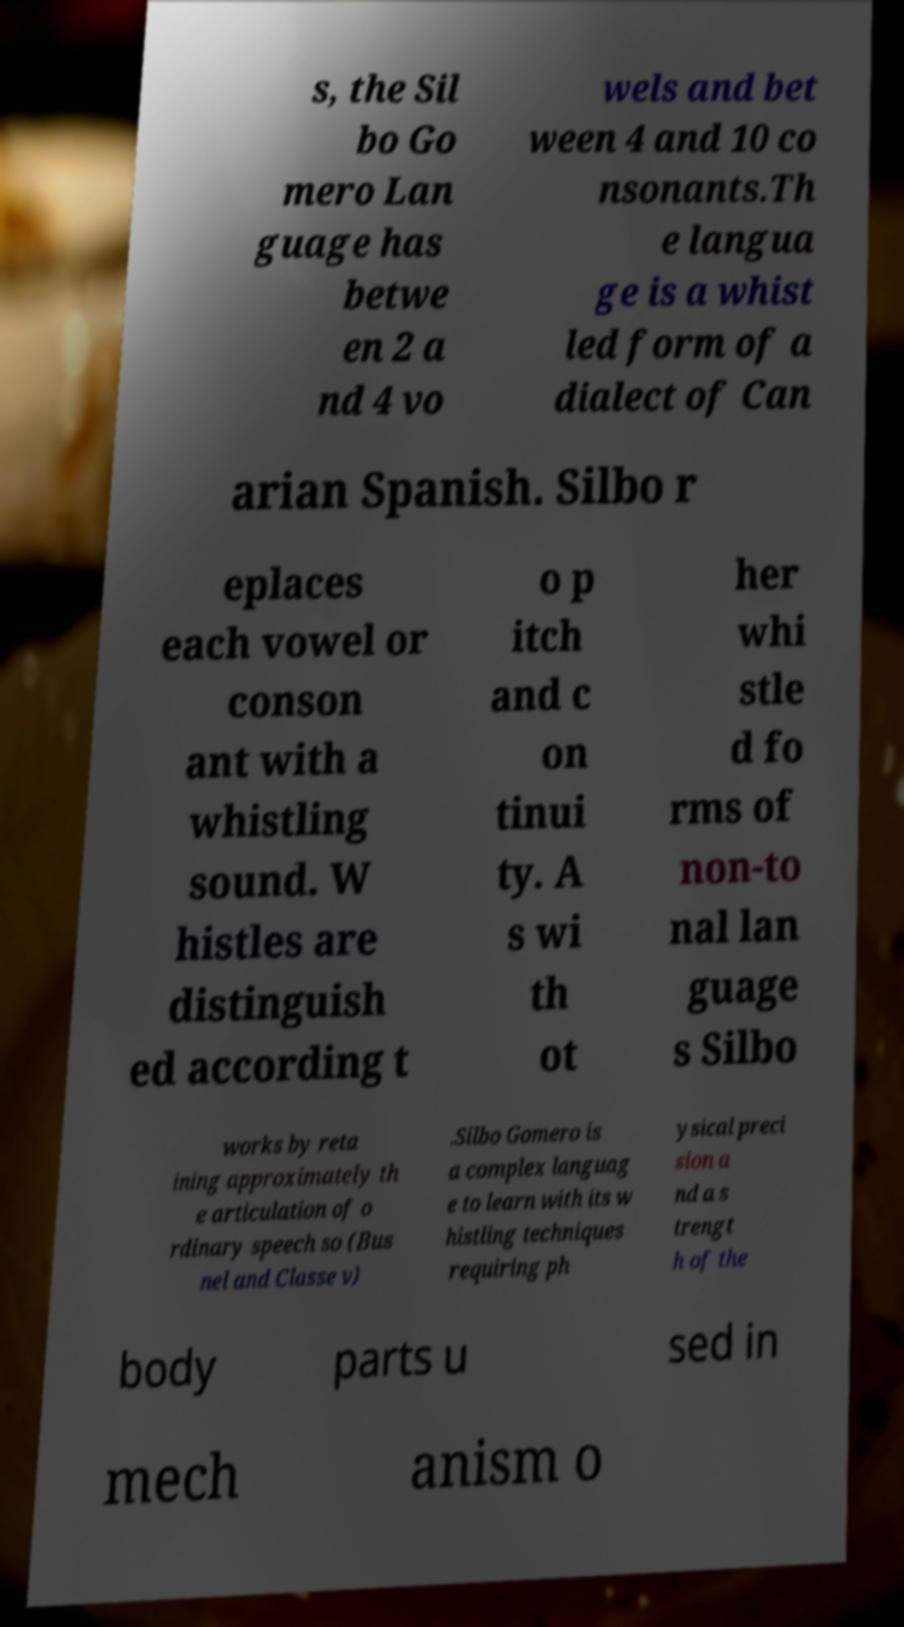Could you extract and type out the text from this image? s, the Sil bo Go mero Lan guage has betwe en 2 a nd 4 vo wels and bet ween 4 and 10 co nsonants.Th e langua ge is a whist led form of a dialect of Can arian Spanish. Silbo r eplaces each vowel or conson ant with a whistling sound. W histles are distinguish ed according t o p itch and c on tinui ty. A s wi th ot her whi stle d fo rms of non-to nal lan guage s Silbo works by reta ining approximately th e articulation of o rdinary speech so (Bus nel and Classe v) .Silbo Gomero is a complex languag e to learn with its w histling techniques requiring ph ysical preci sion a nd a s trengt h of the body parts u sed in mech anism o 